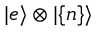Convert formula to latex. <formula><loc_0><loc_0><loc_500><loc_500>| e \rangle \otimes | \{ n \} \rangle</formula> 